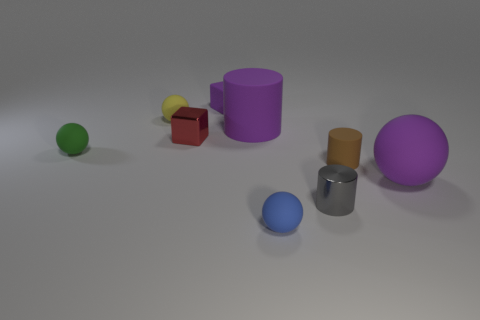Subtract all tiny gray metal cylinders. How many cylinders are left? 2 Subtract all purple spheres. How many spheres are left? 3 Add 1 purple rubber cylinders. How many objects exist? 10 Subtract all cylinders. How many objects are left? 6 Subtract 1 cylinders. How many cylinders are left? 2 Subtract all big balls. Subtract all brown rubber things. How many objects are left? 7 Add 9 small brown cylinders. How many small brown cylinders are left? 10 Add 3 red cubes. How many red cubes exist? 4 Subtract 0 cyan cylinders. How many objects are left? 9 Subtract all brown cylinders. Subtract all yellow balls. How many cylinders are left? 2 